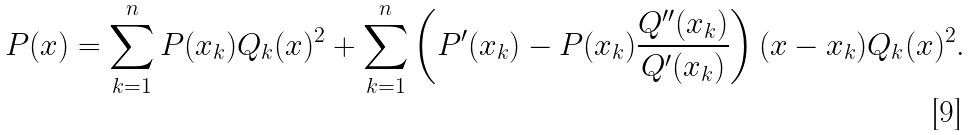Convert formula to latex. <formula><loc_0><loc_0><loc_500><loc_500>P ( x ) = \sum _ { k = 1 } ^ { n } P ( x _ { k } ) Q _ { k } ( x ) ^ { 2 } + \sum _ { k = 1 } ^ { n } \left ( P ^ { \prime } ( x _ { k } ) - P ( x _ { k } ) \frac { Q ^ { \prime \prime } ( x _ { k } ) } { Q ^ { \prime } ( x _ { k } ) } \right ) ( x - x _ { k } ) Q _ { k } ( x ) ^ { 2 } .</formula> 